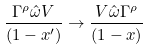<formula> <loc_0><loc_0><loc_500><loc_500>\frac { \Gamma ^ { \rho } \hat { \omega } V } { ( 1 - x ^ { \prime } ) } \rightarrow \frac { V \hat { \omega } \Gamma ^ { \rho } } { ( 1 - x ) }</formula> 